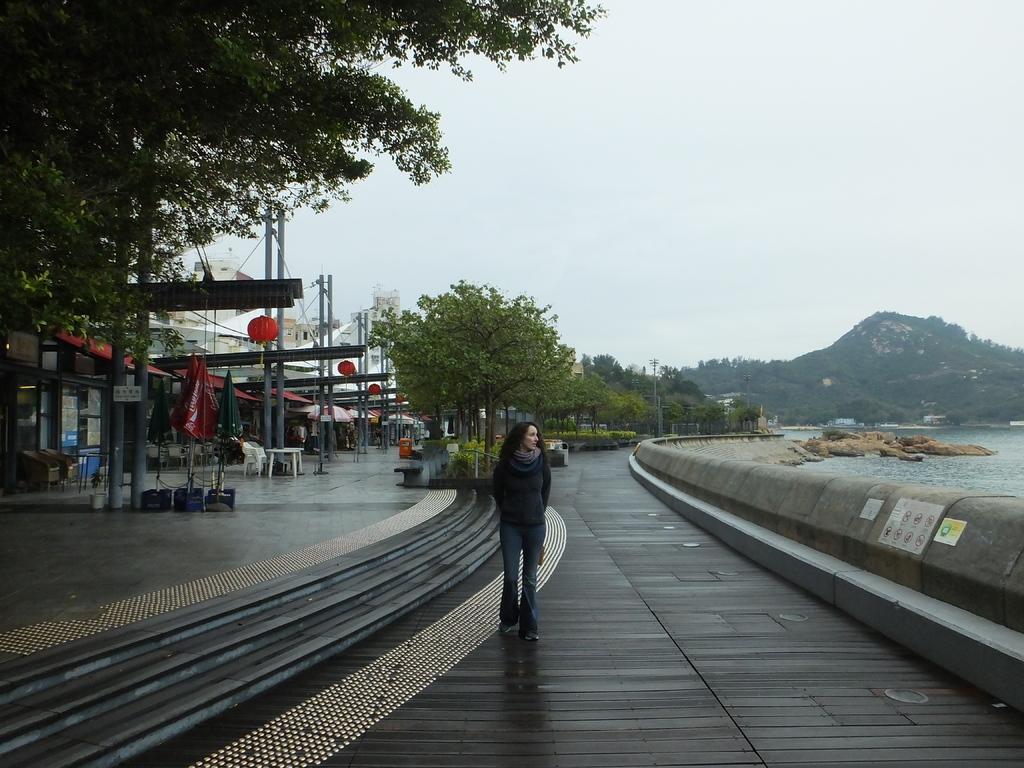Please provide a concise description of this image. This picture shows few buildings and we see trees and water and we see rocks and a woman walking and we see few umbrellas and few chairs and a table. 